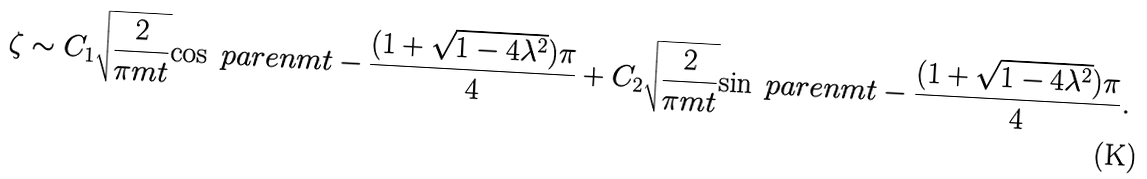<formula> <loc_0><loc_0><loc_500><loc_500>\zeta \sim C _ { 1 } \sqrt { \frac { 2 } { \pi m t } } { \cos \ p a r e n { m t - \frac { ( 1 + \sqrt { 1 - 4 \lambda ^ { 2 } } ) \pi } { 4 } } } + C _ { 2 } \sqrt { \frac { 2 } { \pi m t } } { \sin \ p a r e n { m t - \frac { ( 1 + \sqrt { 1 - 4 \lambda ^ { 2 } } ) \pi } { 4 } } } .</formula> 